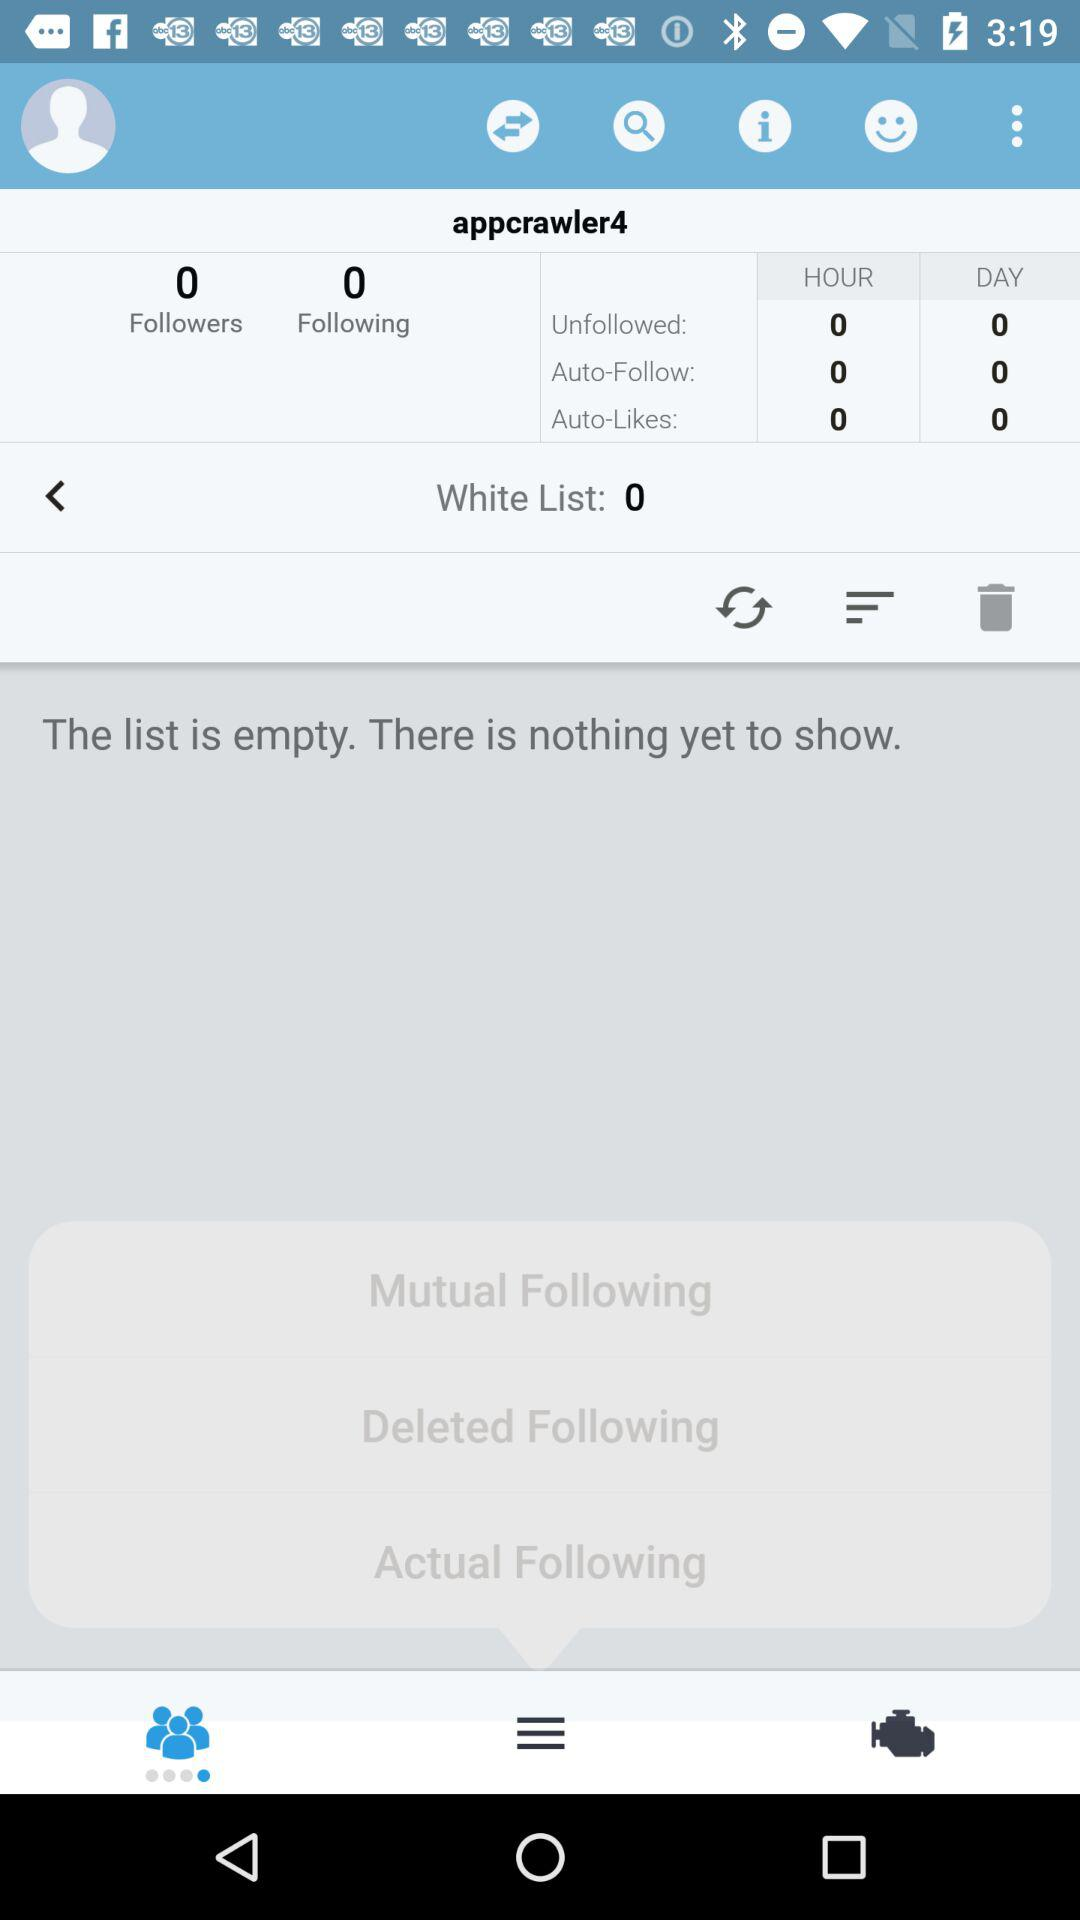What is the name of the user? The name of the user is Appcrawler4. 